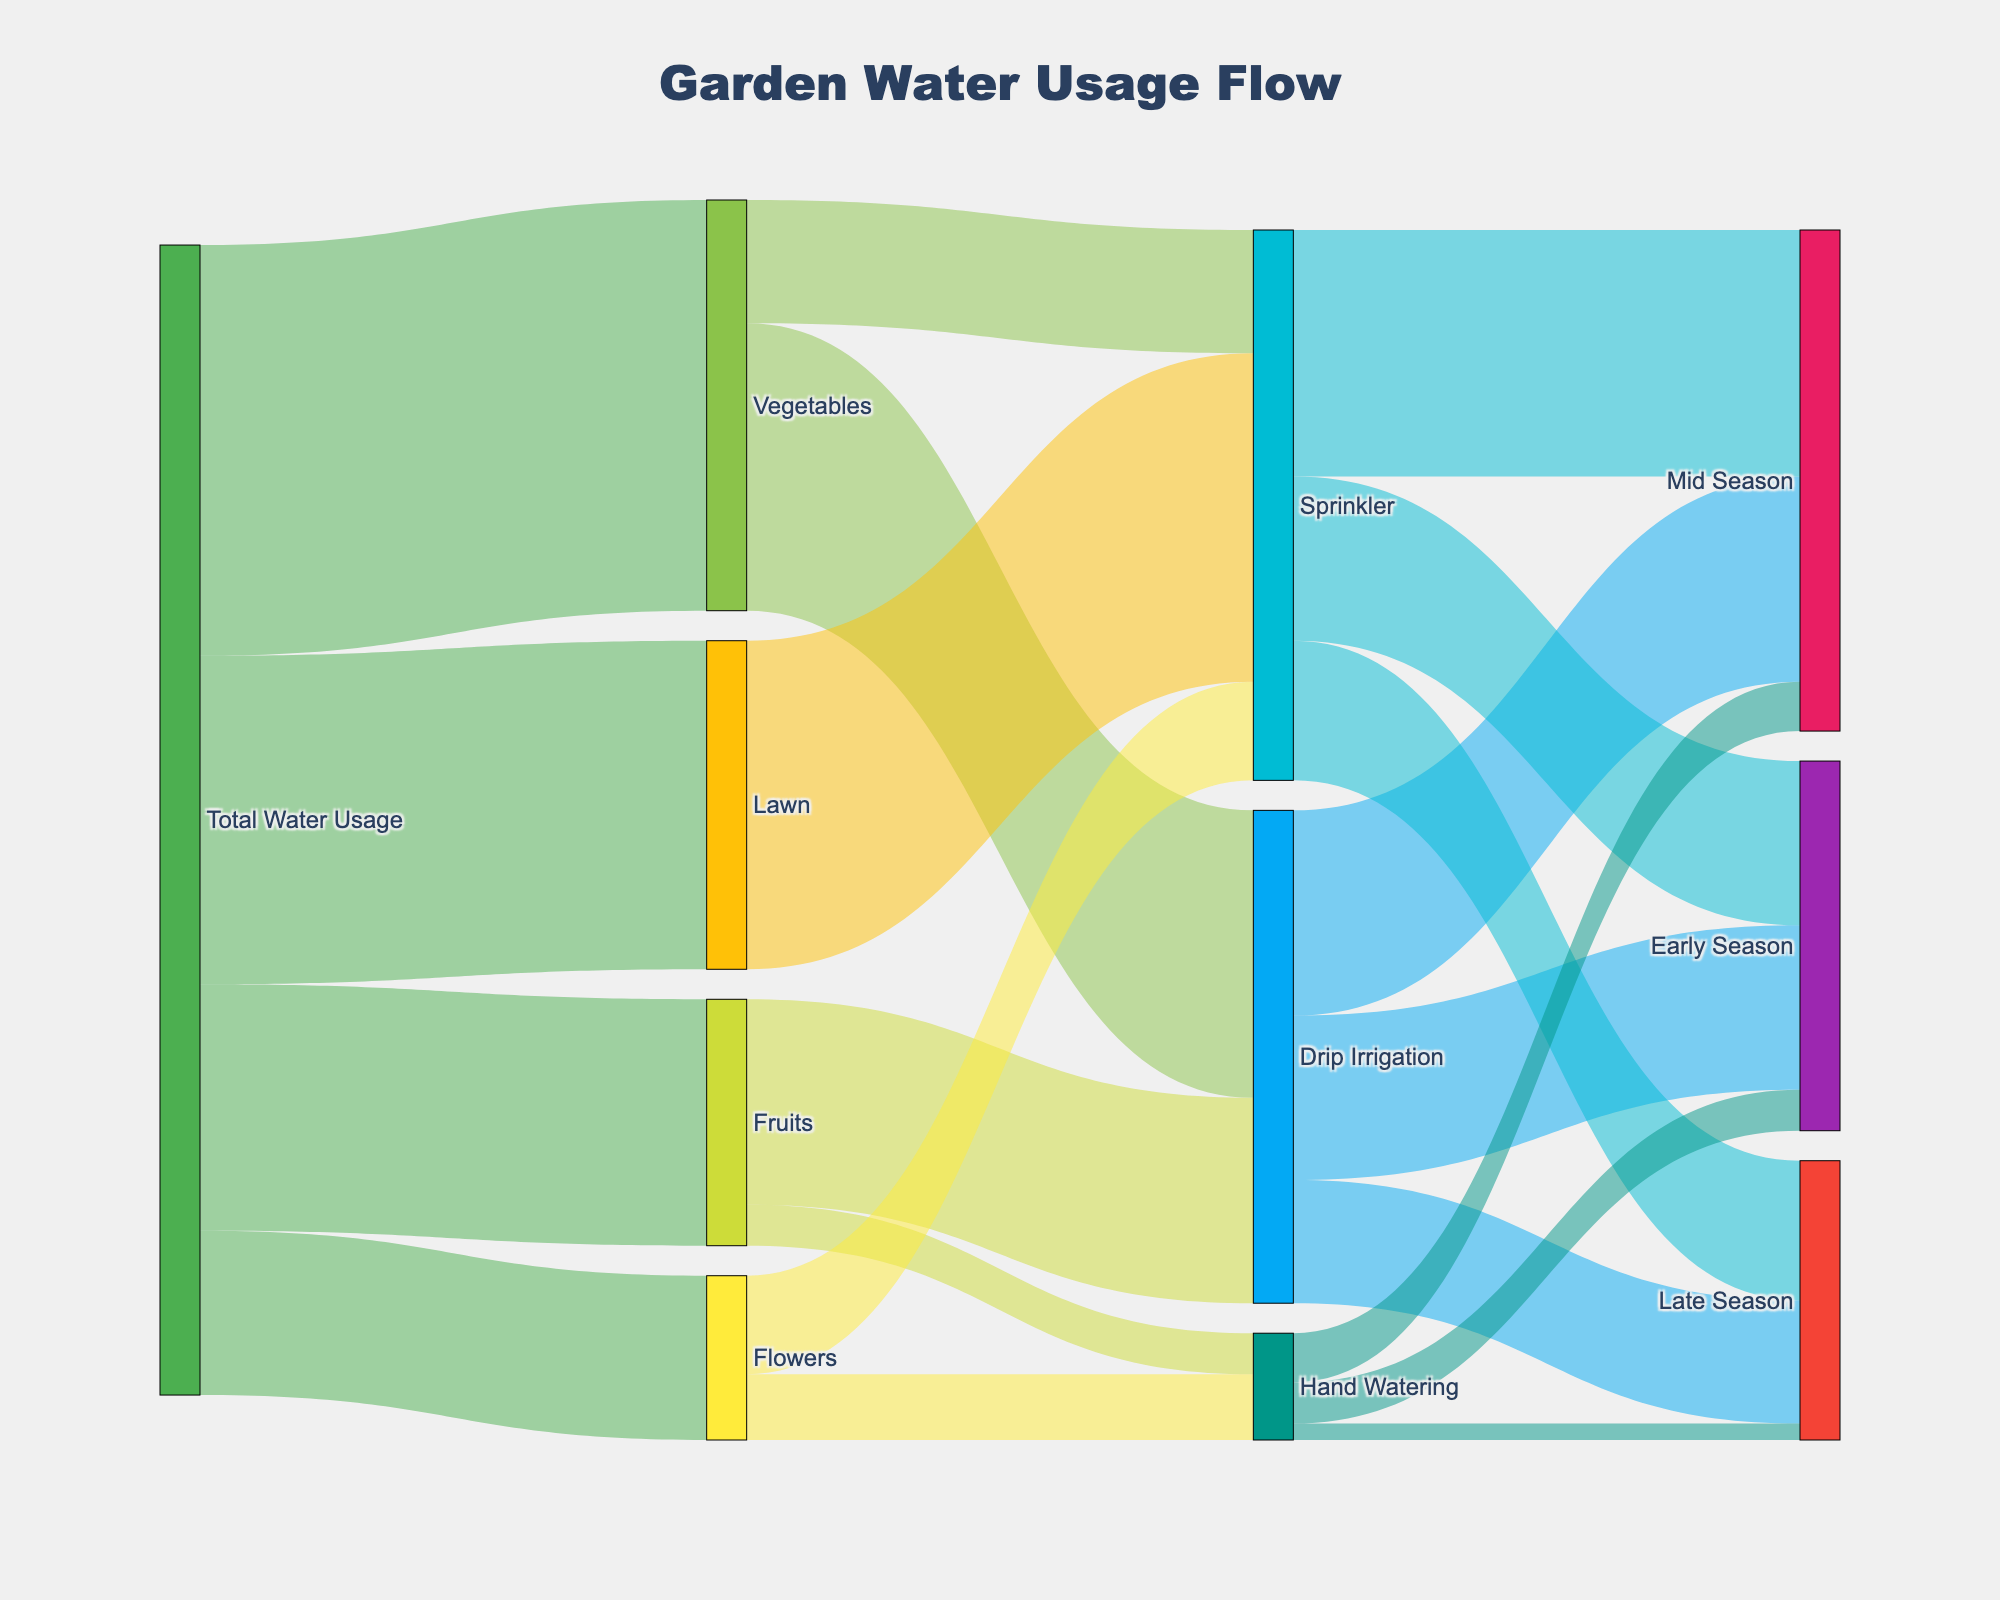what is the total amount of water used for vegetables? Look for the flow from "Total Water Usage" to "Vegetables" in the diagram. The value is indicated as 5000.
Answer: 5000 Which irrigation method uses the most water for Vegetables? Check the flows from "Vegetables" to its irrigation methods. Drip Irrigation uses 3500, while Sprinkler uses 1500.
Answer: Drip Irrigation What is the total water usage for the garden during the growing season? Sum up the values from "Total Water Usage" to Vegetables, Fruits, Flowers, and Lawn. 5000 + 3000 + 2000 + 4000.
Answer: 14000 How does the water usage for Drip Irrigation compare across different growing seasons? Sum the values from Drip Irrigation to Early Season (2000), Mid Season (2500), and Late Season (1500). Compare these values.
Answer: Most in Mid Season How much water is used for lawn care and which method is employed? Identify the flow from "Total Water Usage" to "Lawn" and then from "Lawn" to its irrigation method. The flow shows 4000 for Lawn and all 4000 is used by Sprinkler.
Answer: 4000, Sprinkler 